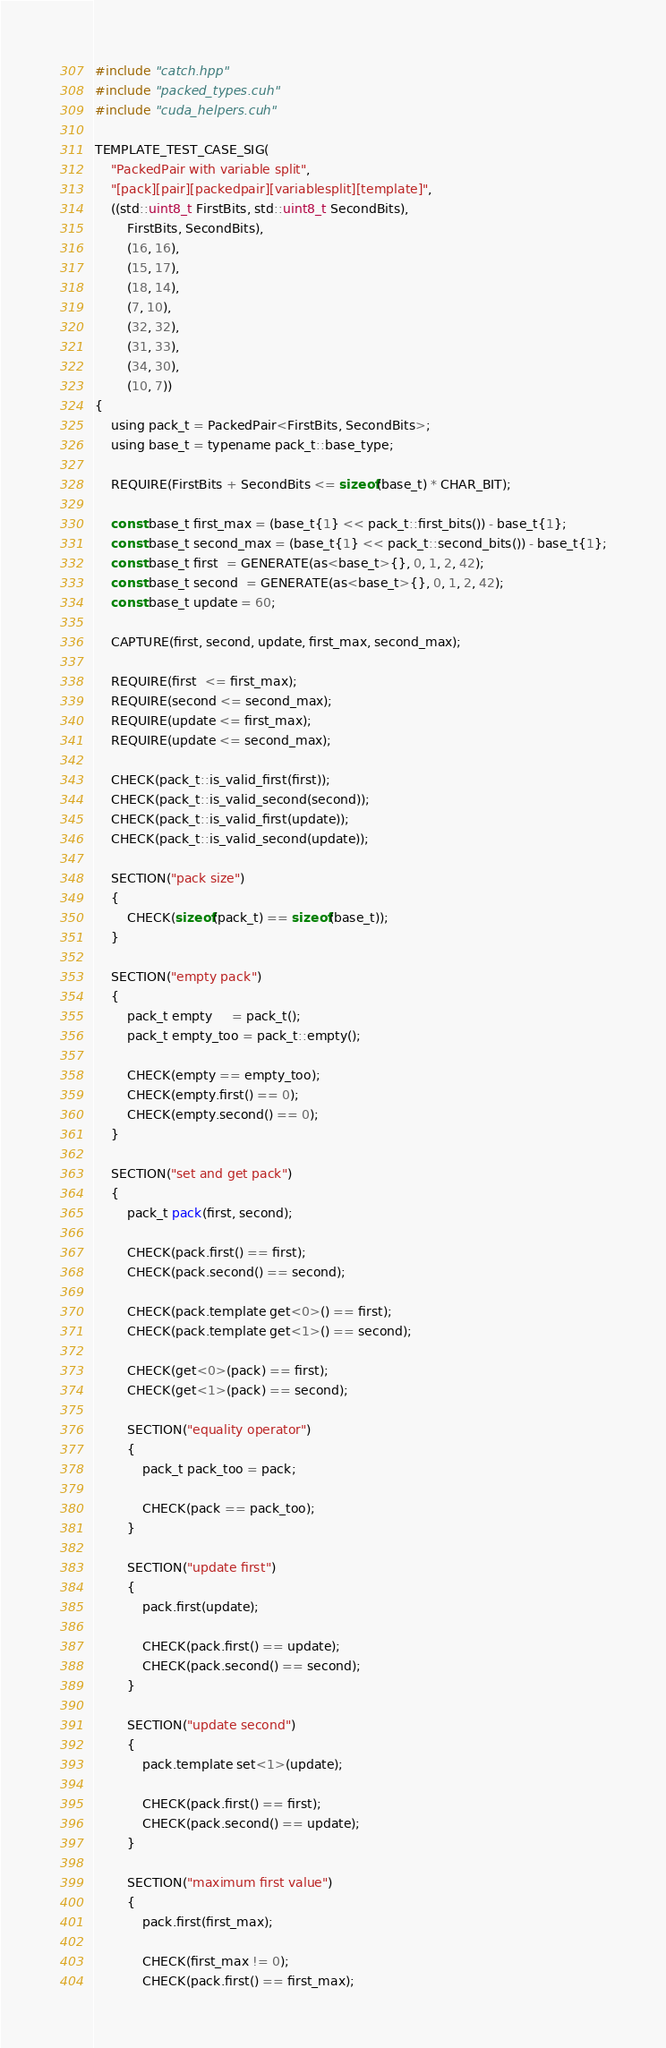<code> <loc_0><loc_0><loc_500><loc_500><_Cuda_>#include "catch.hpp"
#include "packed_types.cuh"
#include "cuda_helpers.cuh"

TEMPLATE_TEST_CASE_SIG(
    "PackedPair with variable split",
    "[pack][pair][packedpair][variablesplit][template]",
    ((std::uint8_t FirstBits, std::uint8_t SecondBits),
        FirstBits, SecondBits),
        (16, 16),
        (15, 17),
        (18, 14),
        (7, 10),
        (32, 32),
        (31, 33),
        (34, 30),
        (10, 7))
{
    using pack_t = PackedPair<FirstBits, SecondBits>;
    using base_t = typename pack_t::base_type;

    REQUIRE(FirstBits + SecondBits <= sizeof(base_t) * CHAR_BIT);

    const base_t first_max = (base_t{1} << pack_t::first_bits()) - base_t{1};
    const base_t second_max = (base_t{1} << pack_t::second_bits()) - base_t{1};
    const base_t first  = GENERATE(as<base_t>{}, 0, 1, 2, 42);
    const base_t second  = GENERATE(as<base_t>{}, 0, 1, 2, 42);
    const base_t update = 60;

    CAPTURE(first, second, update, first_max, second_max);

    REQUIRE(first  <= first_max);
    REQUIRE(second <= second_max);
    REQUIRE(update <= first_max);
    REQUIRE(update <= second_max);

    CHECK(pack_t::is_valid_first(first));
    CHECK(pack_t::is_valid_second(second));
    CHECK(pack_t::is_valid_first(update));
    CHECK(pack_t::is_valid_second(update));

    SECTION("pack size")
    {
        CHECK(sizeof(pack_t) == sizeof(base_t));
    }

    SECTION("empty pack")
    {
        pack_t empty     = pack_t();
        pack_t empty_too = pack_t::empty();

        CHECK(empty == empty_too);
        CHECK(empty.first() == 0);
        CHECK(empty.second() == 0);
    }

    SECTION("set and get pack")
    {
        pack_t pack(first, second);

        CHECK(pack.first() == first);
        CHECK(pack.second() == second);

        CHECK(pack.template get<0>() == first);
        CHECK(pack.template get<1>() == second);

        CHECK(get<0>(pack) == first);
        CHECK(get<1>(pack) == second);

        SECTION("equality operator")
        {
            pack_t pack_too = pack;

            CHECK(pack == pack_too);
        }

        SECTION("update first")
        {
            pack.first(update);

            CHECK(pack.first() == update);
            CHECK(pack.second() == second);
        }

        SECTION("update second")
        {
            pack.template set<1>(update);

            CHECK(pack.first() == first);
            CHECK(pack.second() == update);
        }

        SECTION("maximum first value")
        {
            pack.first(first_max);

            CHECK(first_max != 0);
            CHECK(pack.first() == first_max);</code> 